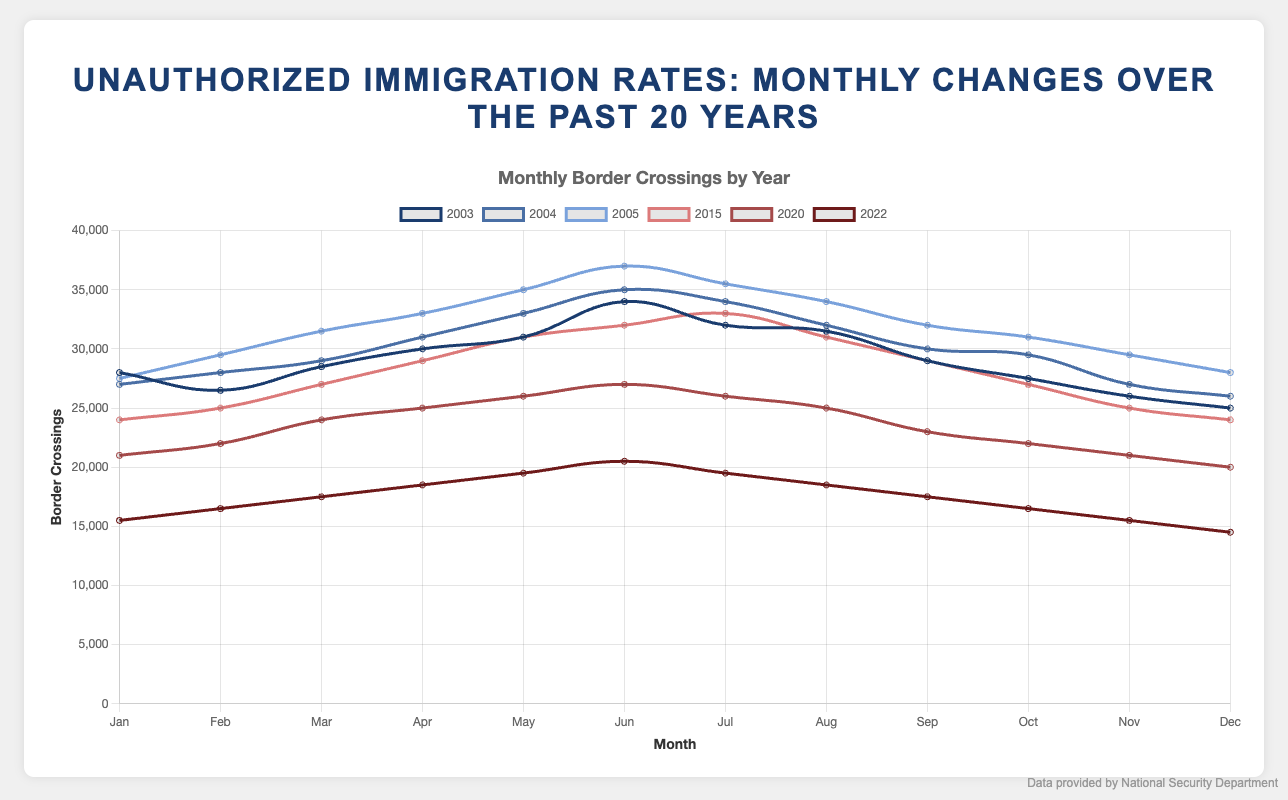What's the trend of unauthorized border crossings from January to December in 2003? By observing the line representing 2003, the unauthorized border crossings show a peak in June at about 34,000 and gradually decline till December, ending at around 25,000.
Answer: Declining Which year had the highest peak in monthly border crossings? We need to look at the peaks in each year. The highest peak is in 2005 in June with about 37,000 unauthorized border crossings.
Answer: 2005 Compare the average monthly border crossings in 2015 and 2022. Which year had the higher average? Calculate the average for each year: 
2015: (24000+25000+27000+29000+31000+32000+33000+31000+29000+27000+25000+24000) / 12 = 28000
2022: (15500+16500+17500+18500+19500+20500+19500+18500+17500+16500+15500+14500) / 12 = 17500
Hence, 2015 had the higher average.
Answer: 2015 How much did the border crossings decrease from January 2020 to December 2020? The border crossings in January 2020 were 21,000 and in December they were 20,000. The decrease is calculated as 21000 - 20000 = 1000.
Answer: 1000 In which year were the border crossings lower in January compared to July? By comparing each year's data, border crossings in January are lower than July in the years 2015 and 2022.
Answer: 2015, 2022 What is the difference between the maximum and minimum monthly border crossings in 2004? The maximum in 2004 is 35,000 (June), and the minimum is 26,000 (November, December). The difference is 35000 - 26000 = 9000.
Answer: 9000 Which year had the most consistently declining trend throughout the year? Observing the trends, 2022 shows a consistent decline from January (15,500) to December (14,500).
Answer: 2022 By how much did the unauthorized border crossings drop from January 2003 to January 2022? The border crossings in January 2003 were 28,000, and in January 2022, they were 15,500. The drop is 28000 - 15500 = 12,500.
Answer: 12500 